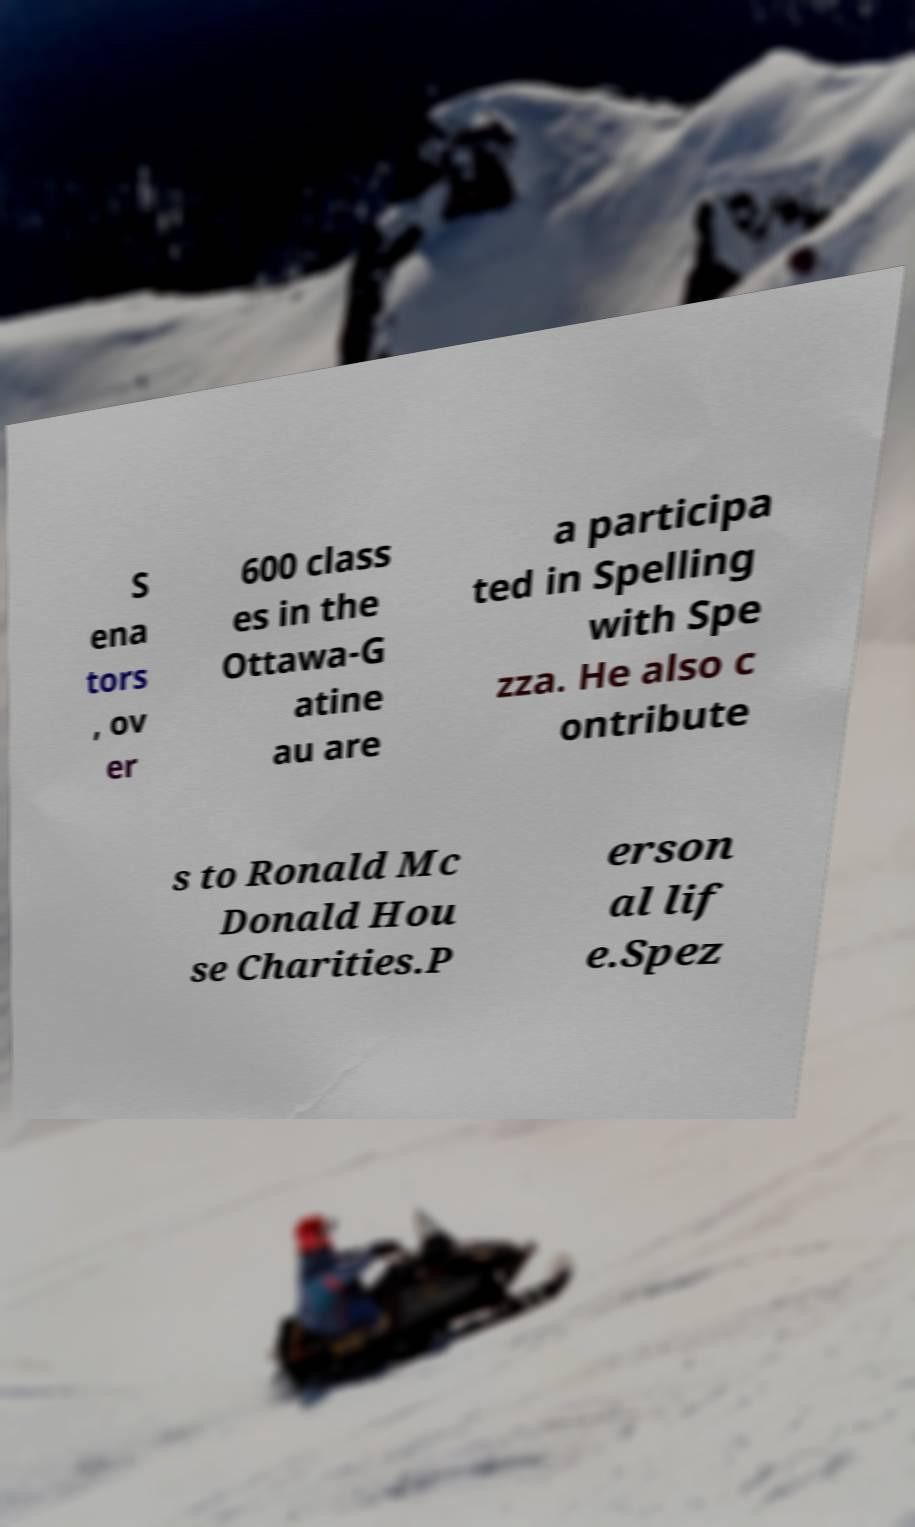For documentation purposes, I need the text within this image transcribed. Could you provide that? S ena tors , ov er 600 class es in the Ottawa-G atine au are a participa ted in Spelling with Spe zza. He also c ontribute s to Ronald Mc Donald Hou se Charities.P erson al lif e.Spez 